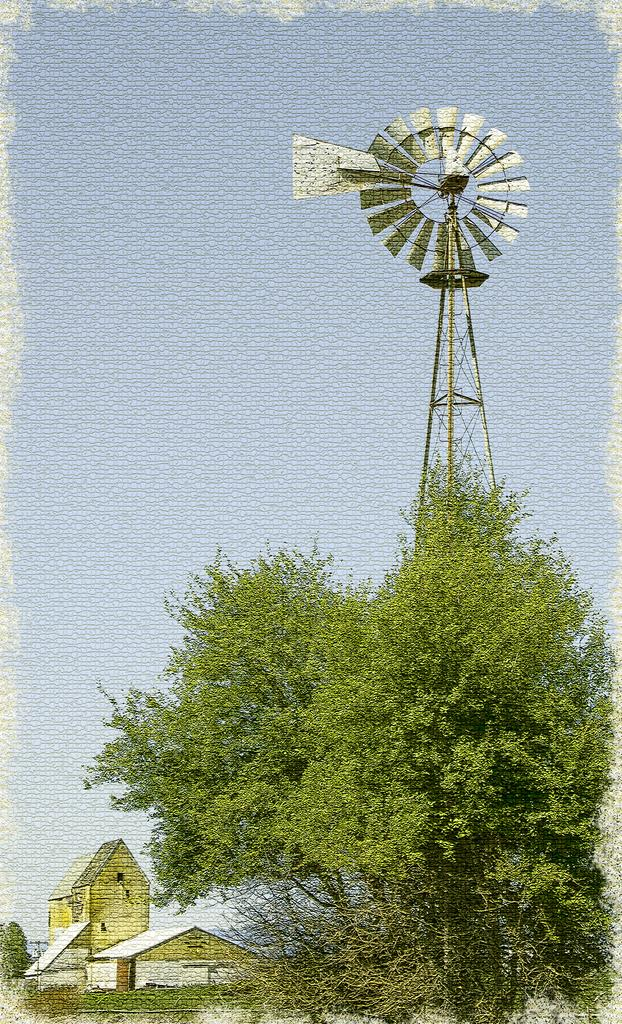What is located on the right side of the foreground in the image? There is a tree on the right side of the foreground. What is behind the tree in the image? There is a wind fan behind the tree. What can be seen in the background of the image? There are houses and greenery in the background. What is visible in the sky in the image? The sky is visible in the background of the image. Where is the mine located in the image? There is no mine present in the image. What type of shelf can be seen in the image? There is no shelf present in the image. 